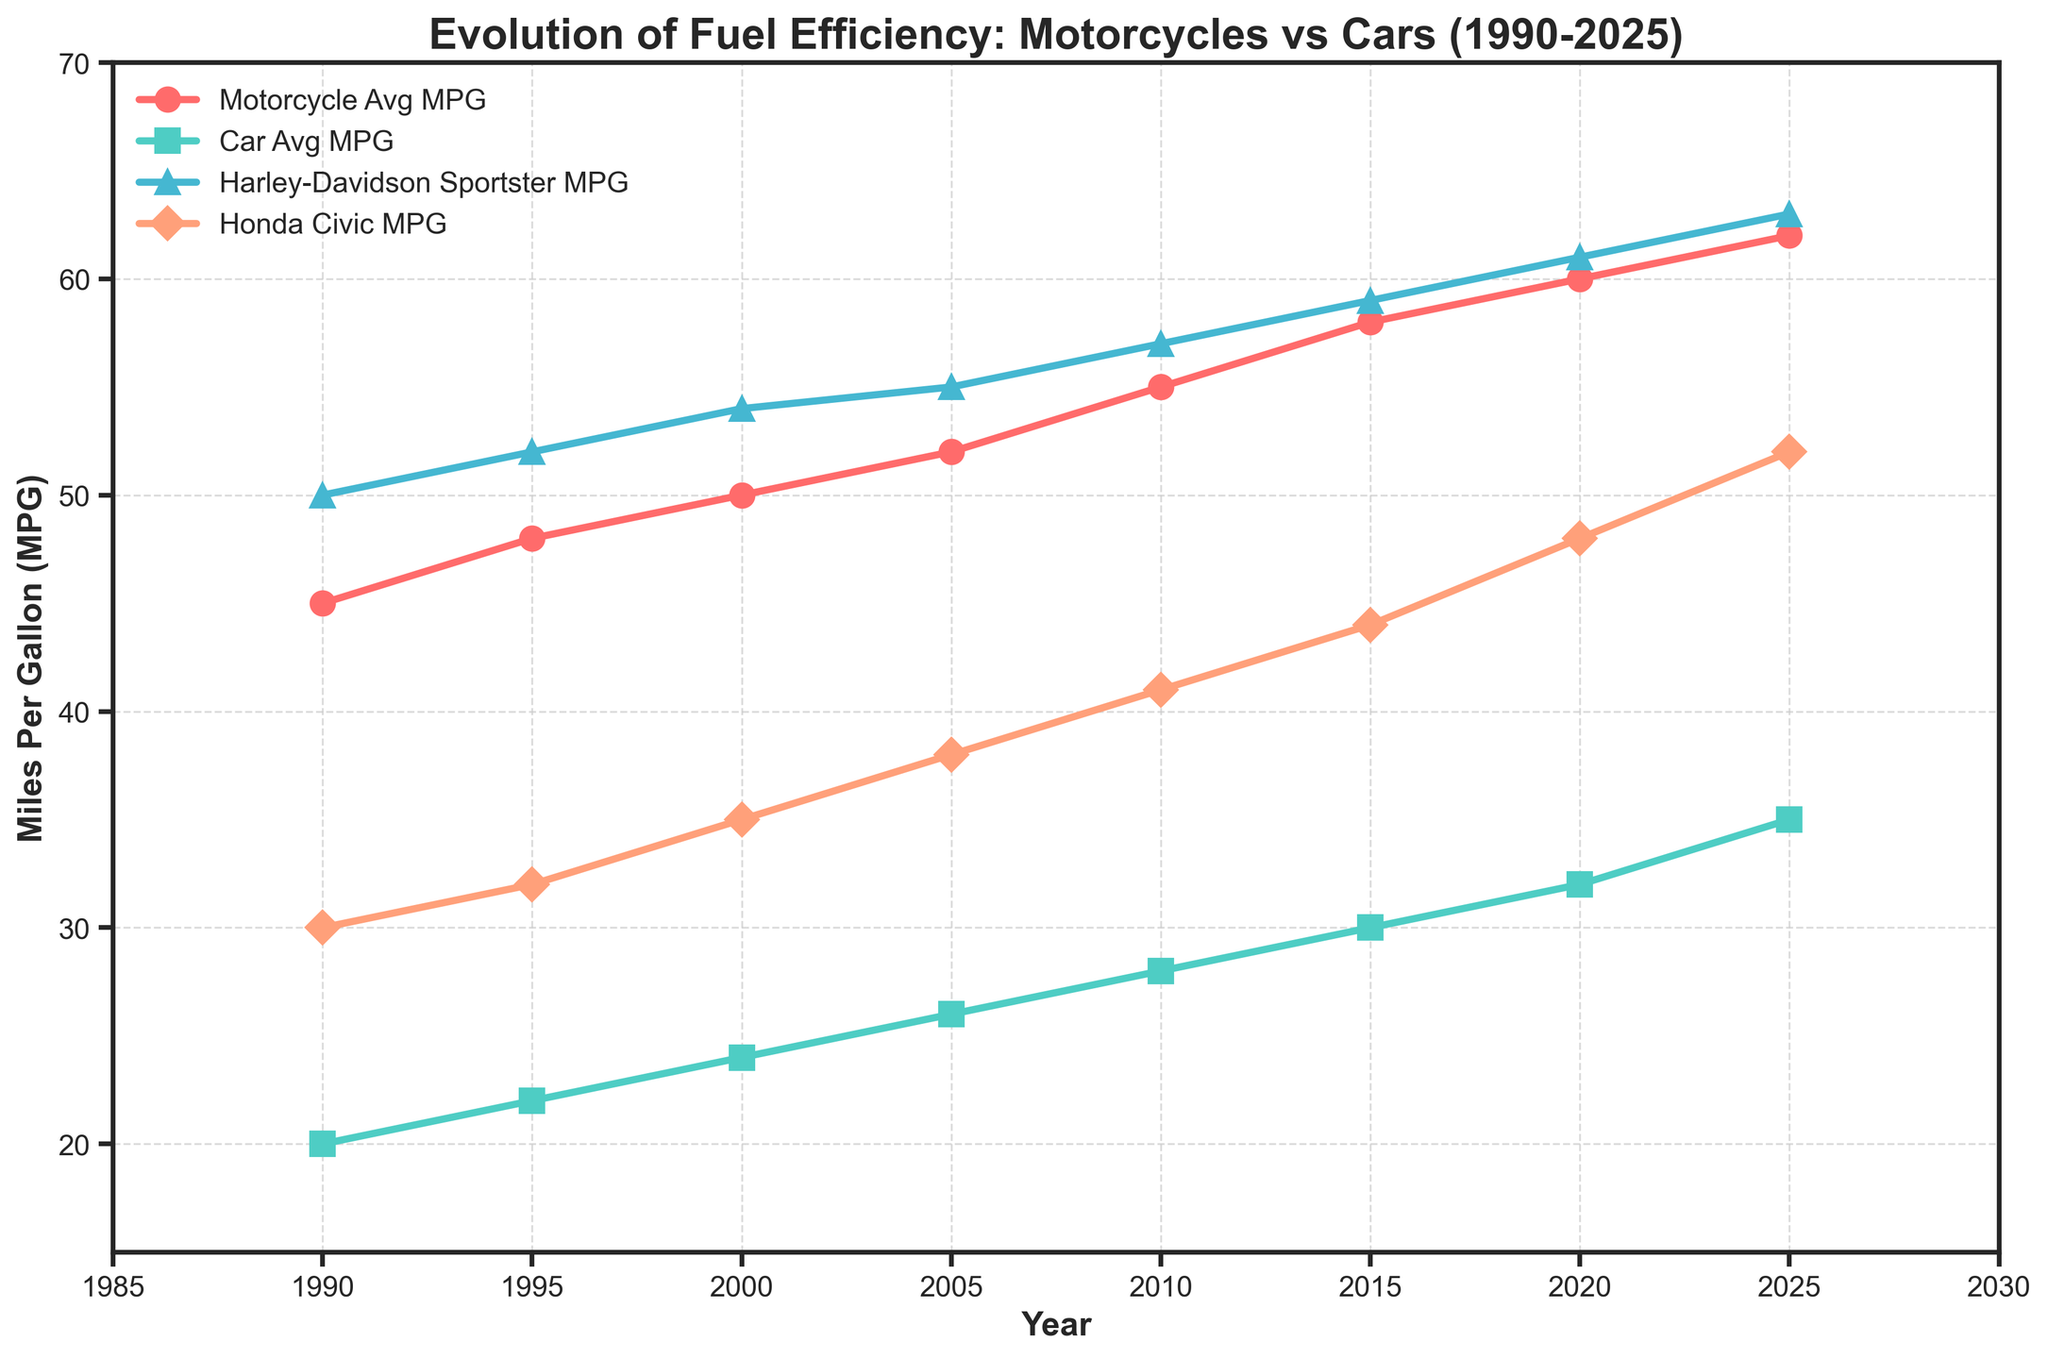Which vehicle type showed a greater average improvement in MPG from 1990 to 2025, motorcycles or cars? Motorcycles increased from 45 MPG to 62 MPG, an improvement of 17 MPG. Cars increased from 20 MPG to 35 MPG, an improvement of 15 MPG.
Answer: Motorcycles By how much did the Harley-Davidson Sportster MPG increase from 1990 to 2025? The Harley-Davidson Sportster increased from 50 MPG in 1990 to 63 MPG in 2025. So, the increase is 63 - 50 = 13 MPG.
Answer: 13 MPG In what year did the Honda Civic's MPG surpass 40 MPG? According to the chart, the Honda Civic's MPG was at 41 in the year 2010.
Answer: 2010 Compare the fuel efficiency between motorcycles and cars in the year 2000. Which was more efficient and by how much? In 2000, motorcycles had an average MPG of 50, while cars had an average MPG of 24. The difference is 50 - 24 = 26 MPG, indicating motorcycles were more efficient by 26 MPG.
Answer: Motorcycles, by 26 MPG Did the average fuel efficiency of cars ever reach the average fuel efficiency of motorcycles any year? The chart shows that motorcycles always maintained a higher average MPG compared to cars throughout the years.
Answer: No Which vehicle showed the most improvement between 2015 and 2020, the Harley-Davidson Sportster or the Honda Civic? Between 2015 and 2020, the Harley-Davidson Sportster improved from 59 MPG to 61 MPG, an improvement of 2 MPG. The Honda Civic improved from 44 MPG to 48 MPG, an improvement of 4 MPG.
Answer: Honda Civic In which year was the difference in MPG between motorcycles and cars the greatest? The greatest difference appears to be in the year 1990, with motorcycles at 45 MPG and cars at 20 MPG, giving a difference of 25 MPG.
Answer: 1990 What was the average fuel efficiency of the motorcycles and cars combined in the year 2010? In 2010, the motorcycles had an average MPG of 55, and cars had 28 MPG. The combined average MPG is (55 + 28) / 2 = 41.5 MPG.
Answer: 41.5 MPG 